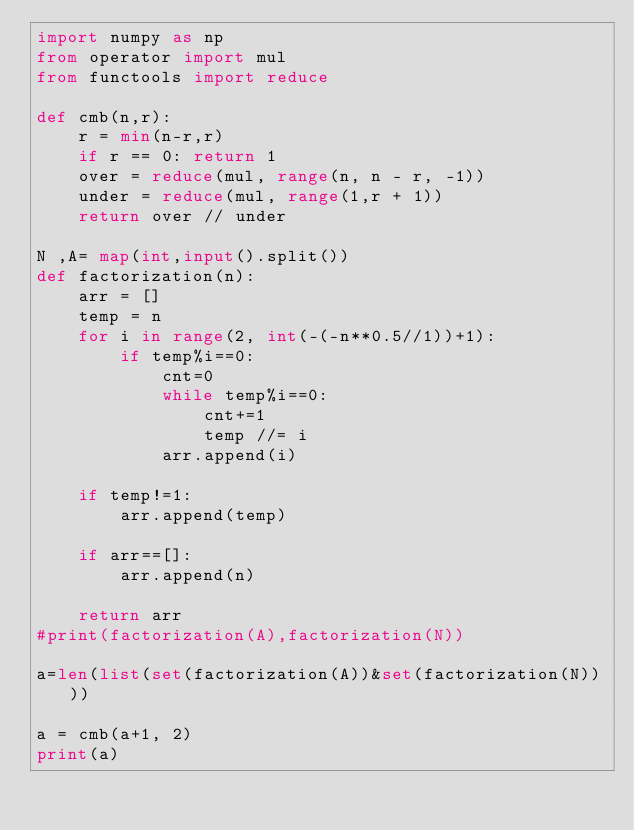Convert code to text. <code><loc_0><loc_0><loc_500><loc_500><_Python_>import numpy as np
from operator import mul
from functools import reduce

def cmb(n,r):
    r = min(n-r,r)
    if r == 0: return 1
    over = reduce(mul, range(n, n - r, -1))
    under = reduce(mul, range(1,r + 1))
    return over // under

N ,A= map(int,input().split())
def factorization(n):
    arr = []
    temp = n
    for i in range(2, int(-(-n**0.5//1))+1):
        if temp%i==0:
            cnt=0
            while temp%i==0:
                cnt+=1
                temp //= i
            arr.append(i)

    if temp!=1:
        arr.append(temp)

    if arr==[]:
        arr.append(n)

    return arr
#print(factorization(A),factorization(N))

a=len(list(set(factorization(A))&set(factorization(N))))

a = cmb(a+1, 2)
print(a)</code> 